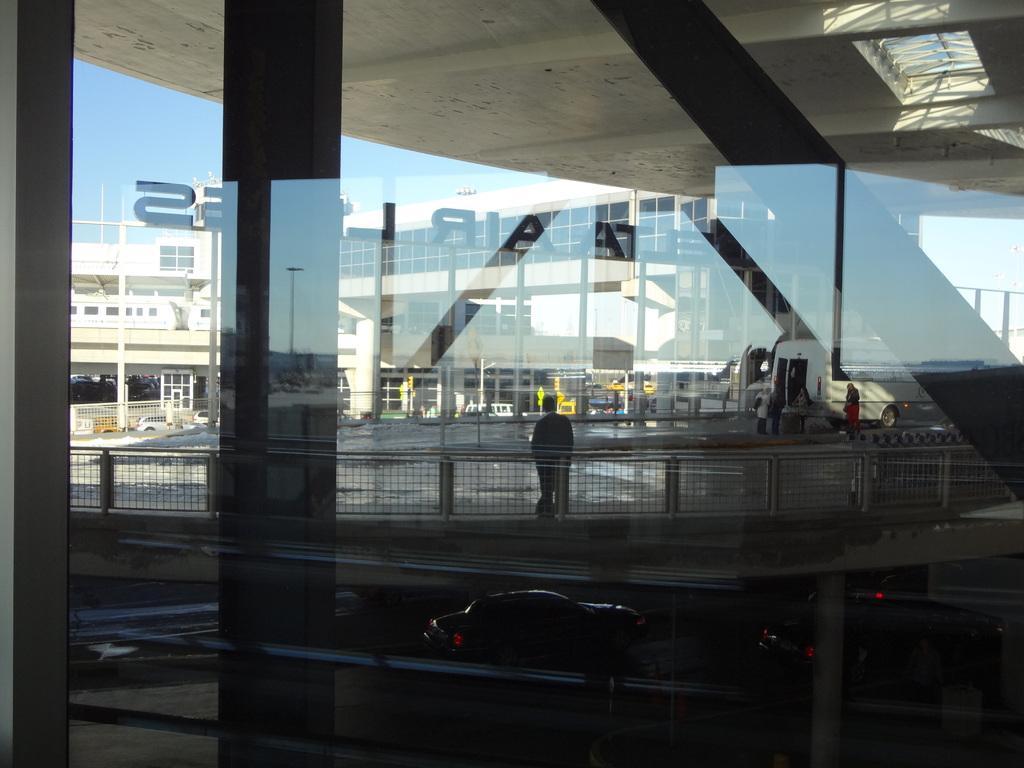Can you describe this image briefly? In this picture we can see the glass, fences, vehicles, some people, buildings, some objects and in the background we can see the sky. 